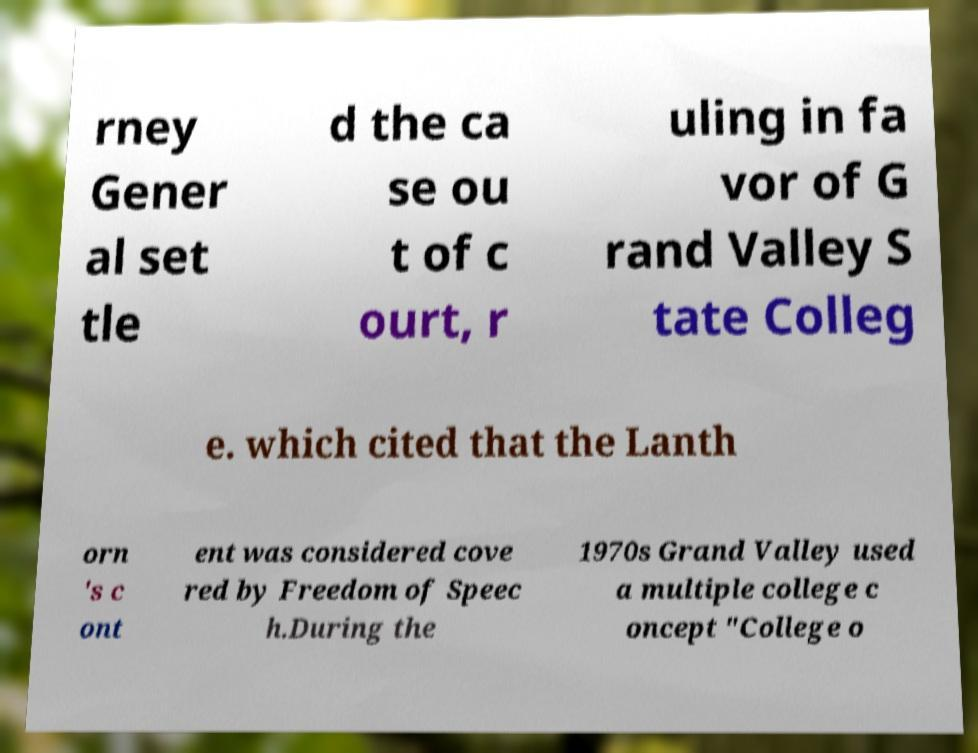I need the written content from this picture converted into text. Can you do that? rney Gener al set tle d the ca se ou t of c ourt, r uling in fa vor of G rand Valley S tate Colleg e. which cited that the Lanth orn 's c ont ent was considered cove red by Freedom of Speec h.During the 1970s Grand Valley used a multiple college c oncept "College o 